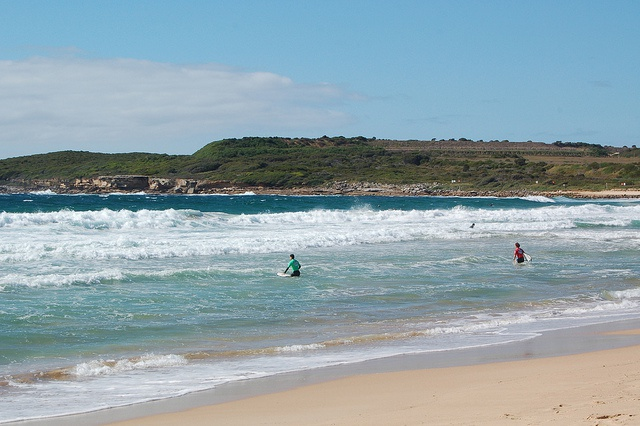Describe the objects in this image and their specific colors. I can see people in lightblue, black, teal, and darkgray tones, people in lightblue, black, maroon, gray, and darkgray tones, surfboard in lightblue, lightgray, darkgray, and gray tones, surfboard in lightblue, lightgray, darkgray, gray, and purple tones, and people in lightblue, gray, white, and darkgray tones in this image. 